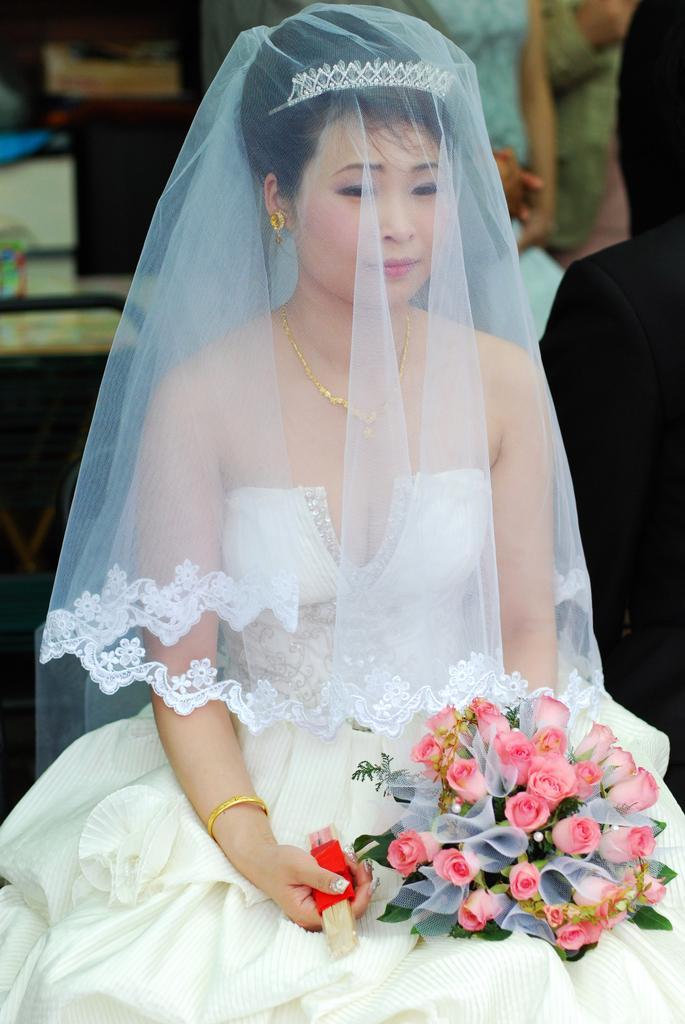Please provide a concise description of this image. In this picture there is a woman who is wearing white dress, bangles, earrings, locket and crown. She is holding the flowers bouquet and some red object. She is sitting on the chair. In the back I can see some people who are standing near to the table. 